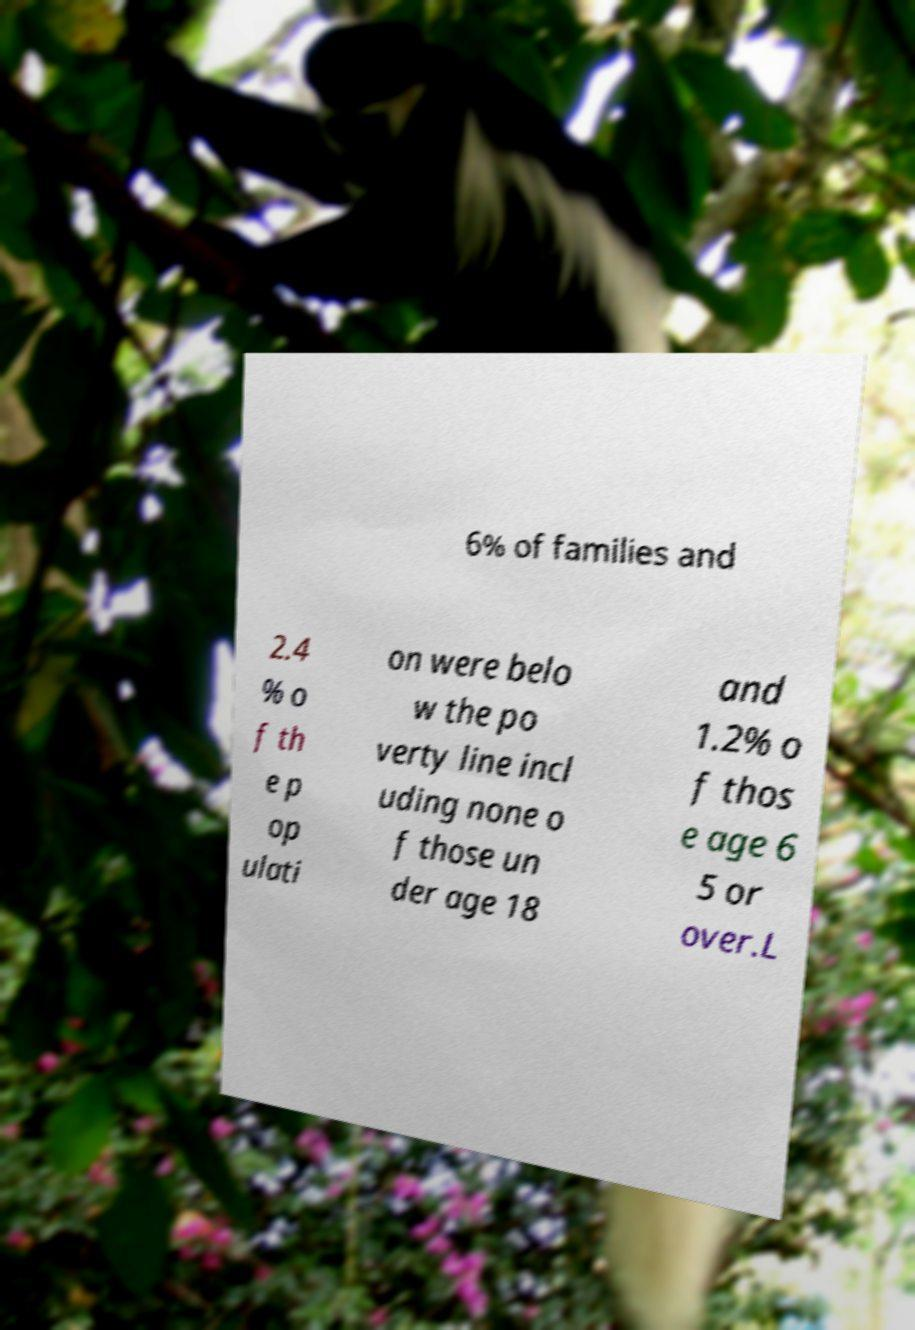Can you accurately transcribe the text from the provided image for me? 6% of families and 2.4 % o f th e p op ulati on were belo w the po verty line incl uding none o f those un der age 18 and 1.2% o f thos e age 6 5 or over.L 